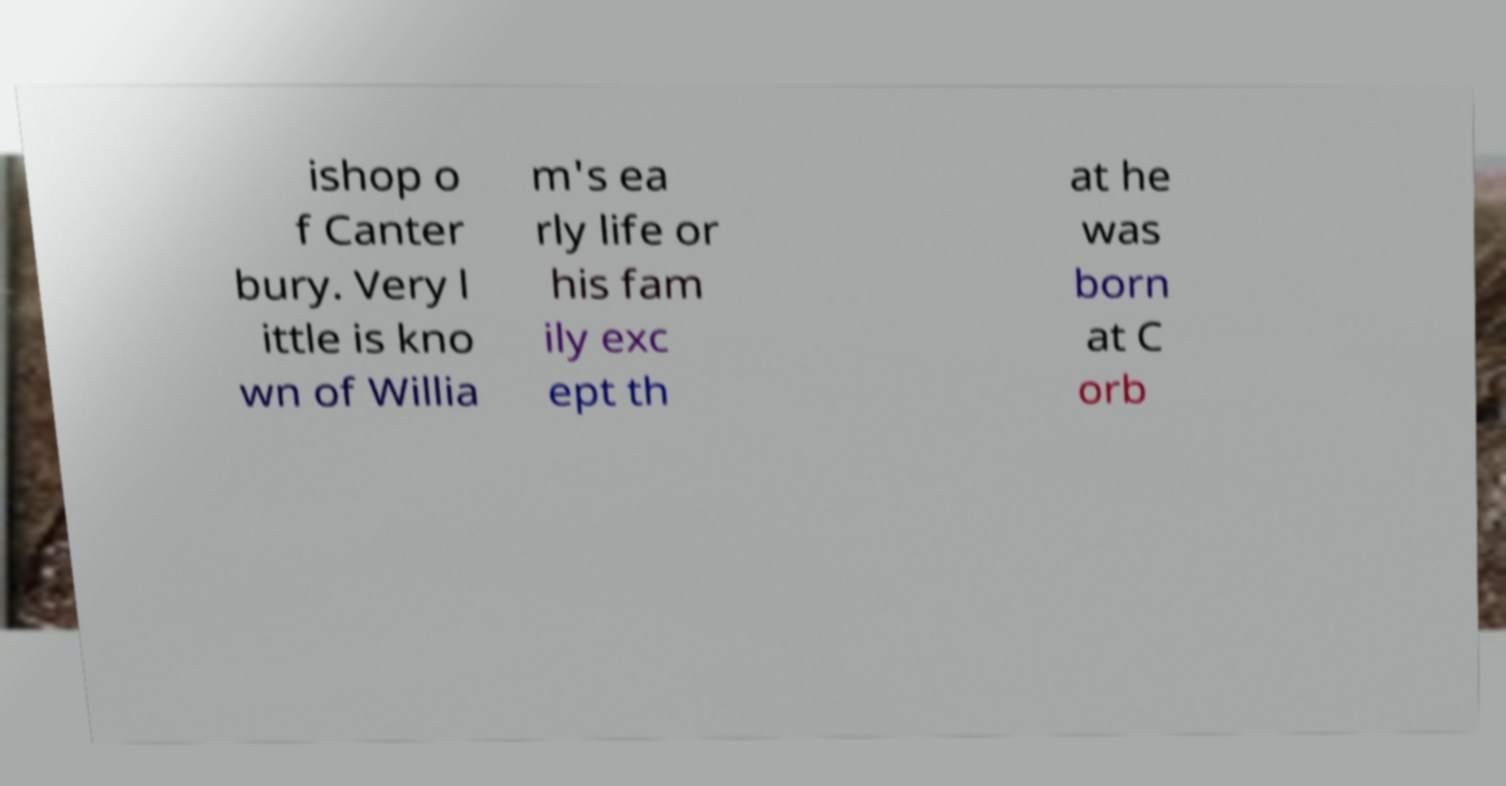Can you accurately transcribe the text from the provided image for me? ishop o f Canter bury. Very l ittle is kno wn of Willia m's ea rly life or his fam ily exc ept th at he was born at C orb 